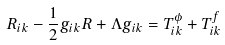Convert formula to latex. <formula><loc_0><loc_0><loc_500><loc_500>R _ { i k } - \frac { 1 } { 2 } g _ { i k } R + \Lambda g _ { i k } = T _ { i k } ^ { \phi } + T _ { i k } ^ { f }</formula> 